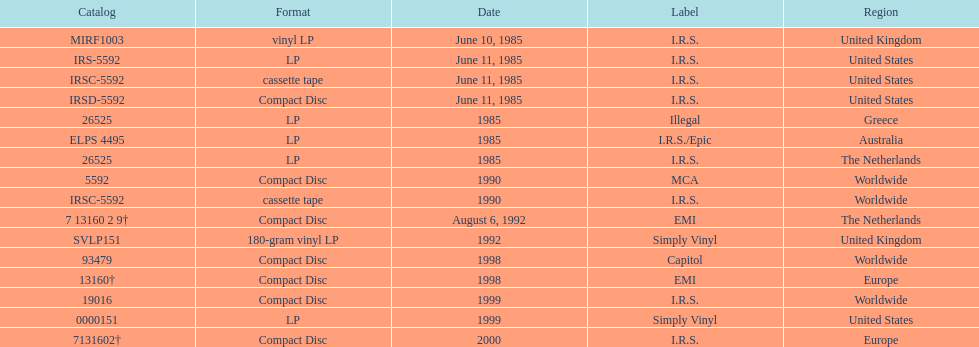Which dates were their releases by fables of the reconstruction? June 10, 1985, June 11, 1985, June 11, 1985, June 11, 1985, 1985, 1985, 1985, 1990, 1990, August 6, 1992, 1992, 1998, 1998, 1999, 1999, 2000. Which of these are in 1985? June 10, 1985, June 11, 1985, June 11, 1985, June 11, 1985, 1985, 1985, 1985. What regions were there releases on these dates? United Kingdom, United States, United States, United States, Greece, Australia, The Netherlands. Which of these are not greece? United Kingdom, United States, United States, United States, Australia, The Netherlands. Which of these regions have two labels listed? Australia. 